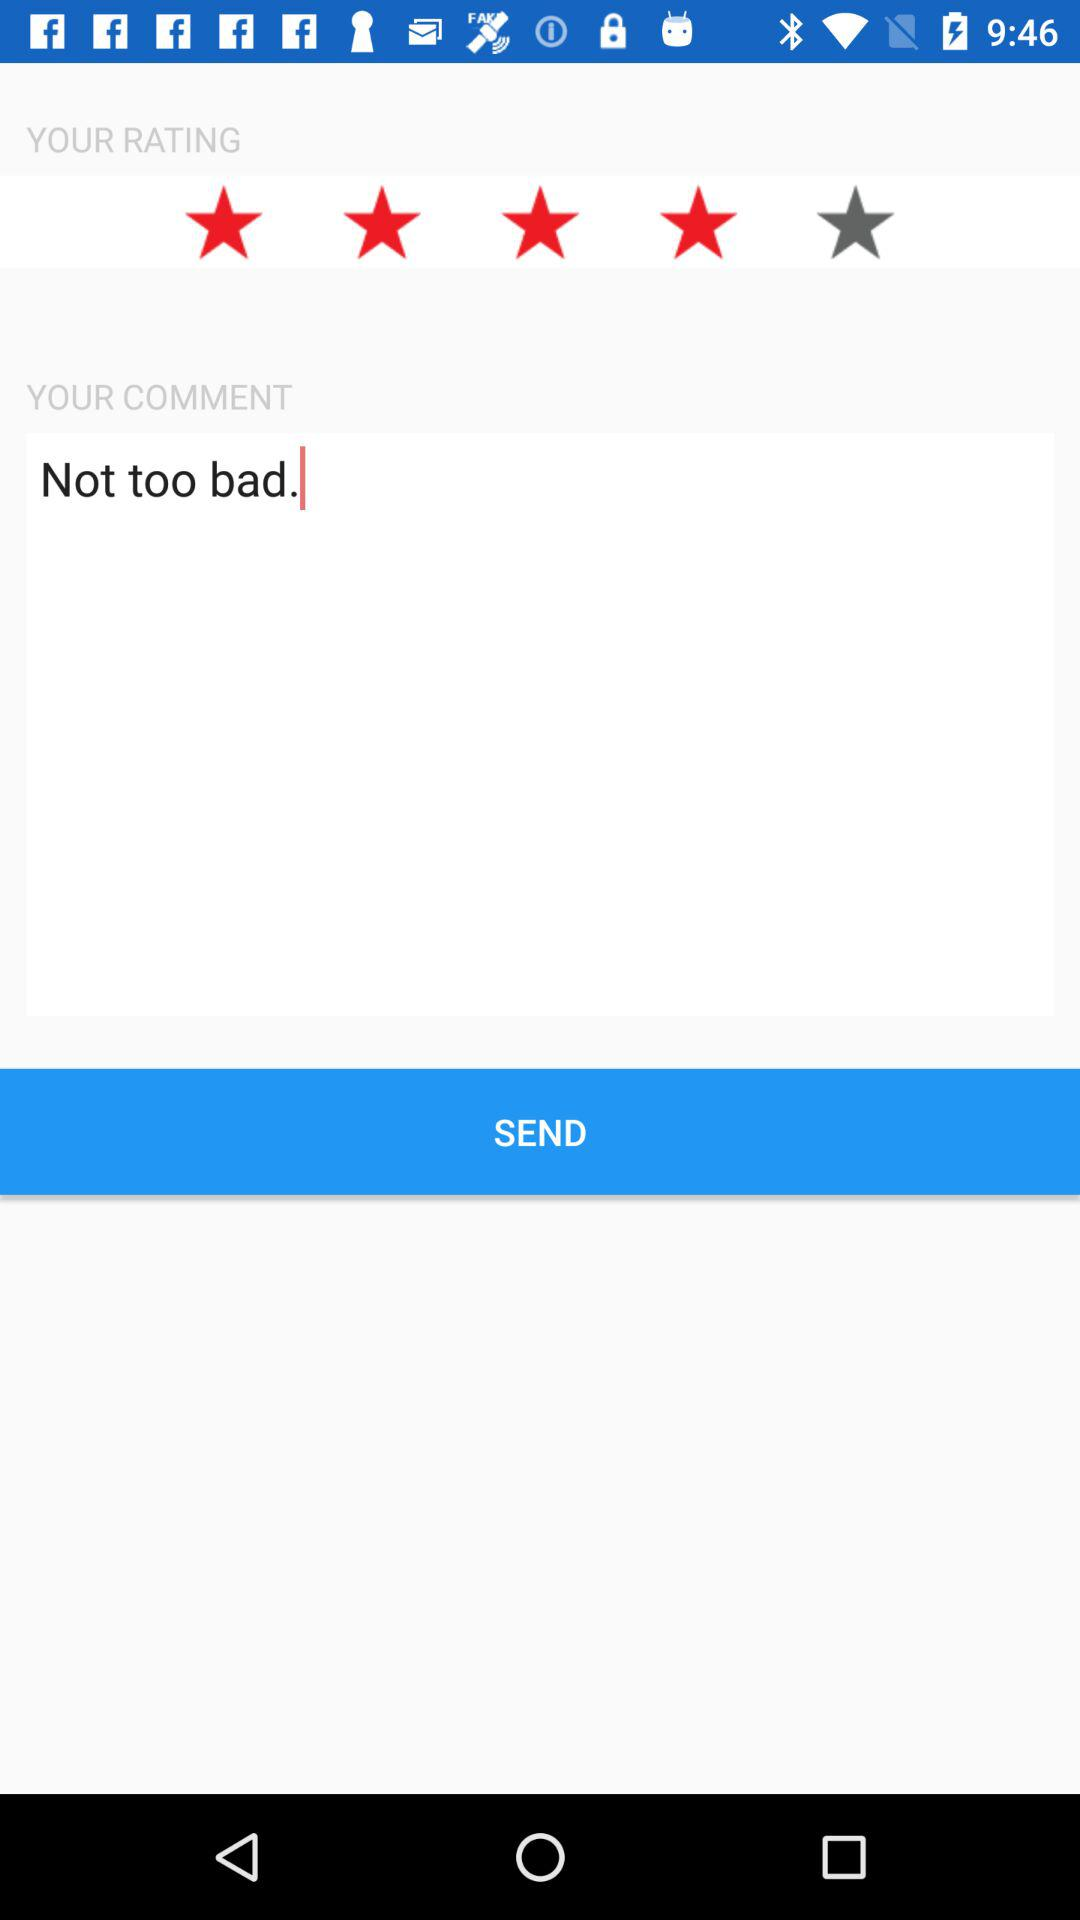What is the rating? The rating is 4 stars. 